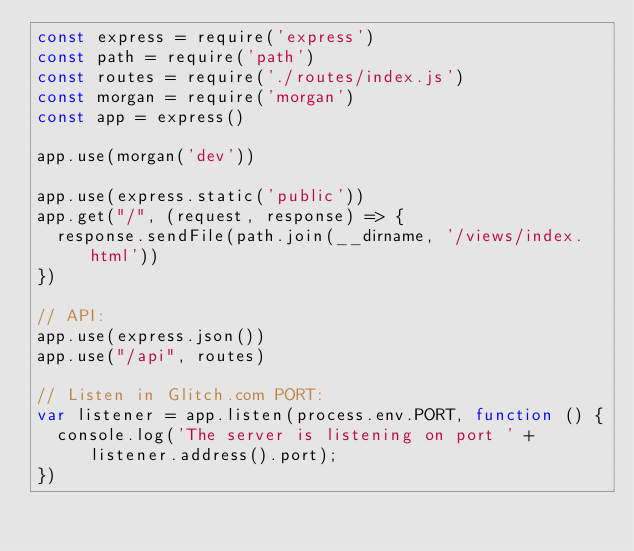<code> <loc_0><loc_0><loc_500><loc_500><_JavaScript_>const express = require('express')
const path = require('path')
const routes = require('./routes/index.js')
const morgan = require('morgan')
const app = express()

app.use(morgan('dev'))

app.use(express.static('public'))
app.get("/", (request, response) => {
  response.sendFile(path.join(__dirname, '/views/index.html'))
})

// API:
app.use(express.json())
app.use("/api", routes)

// Listen in Glitch.com PORT:
var listener = app.listen(process.env.PORT, function () {
  console.log('The server is listening on port ' + listener.address().port);
})
</code> 